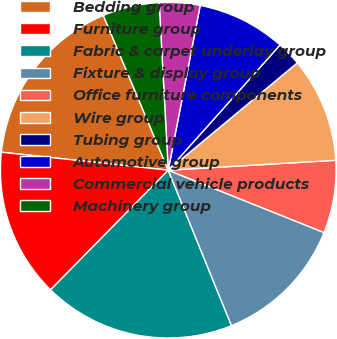Convert chart to OTSL. <chart><loc_0><loc_0><loc_500><loc_500><pie_chart><fcel>Bedding group<fcel>Furniture group<fcel>Fabric & carpet underlay group<fcel>Fixture & display group<fcel>Office furniture components<fcel>Wire group<fcel>Tubing group<fcel>Automotive group<fcel>Commercial vehicle products<fcel>Machinery group<nl><fcel>16.97%<fcel>14.34%<fcel>18.52%<fcel>12.79%<fcel>7.0%<fcel>10.1%<fcel>2.36%<fcel>8.55%<fcel>3.91%<fcel>5.46%<nl></chart> 